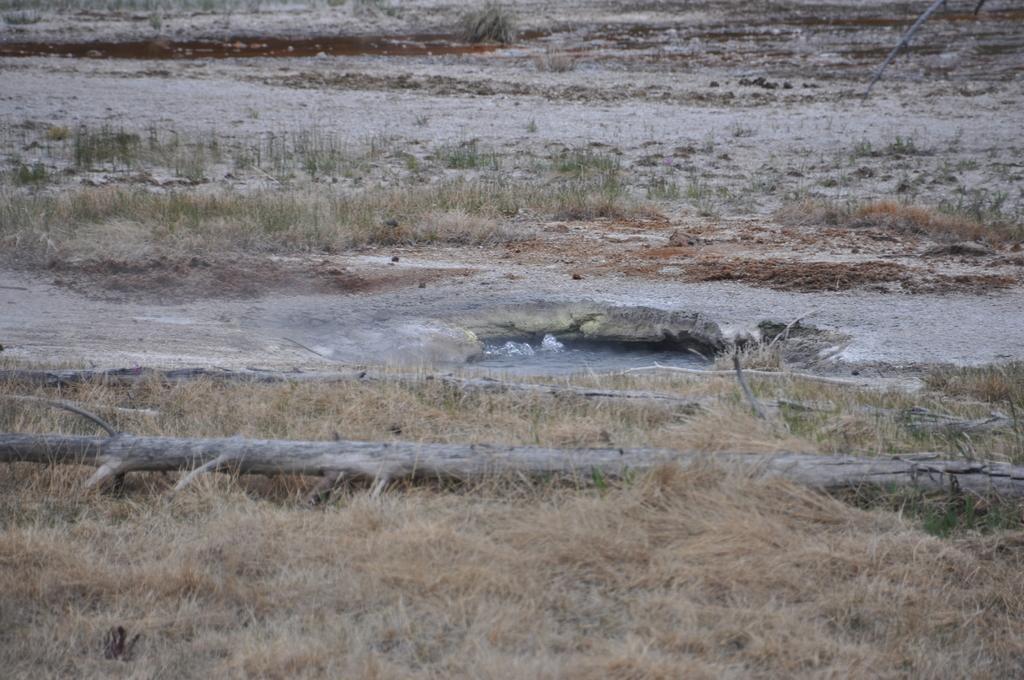Can you describe this image briefly? In this image we can see dried grass, water and branch. 